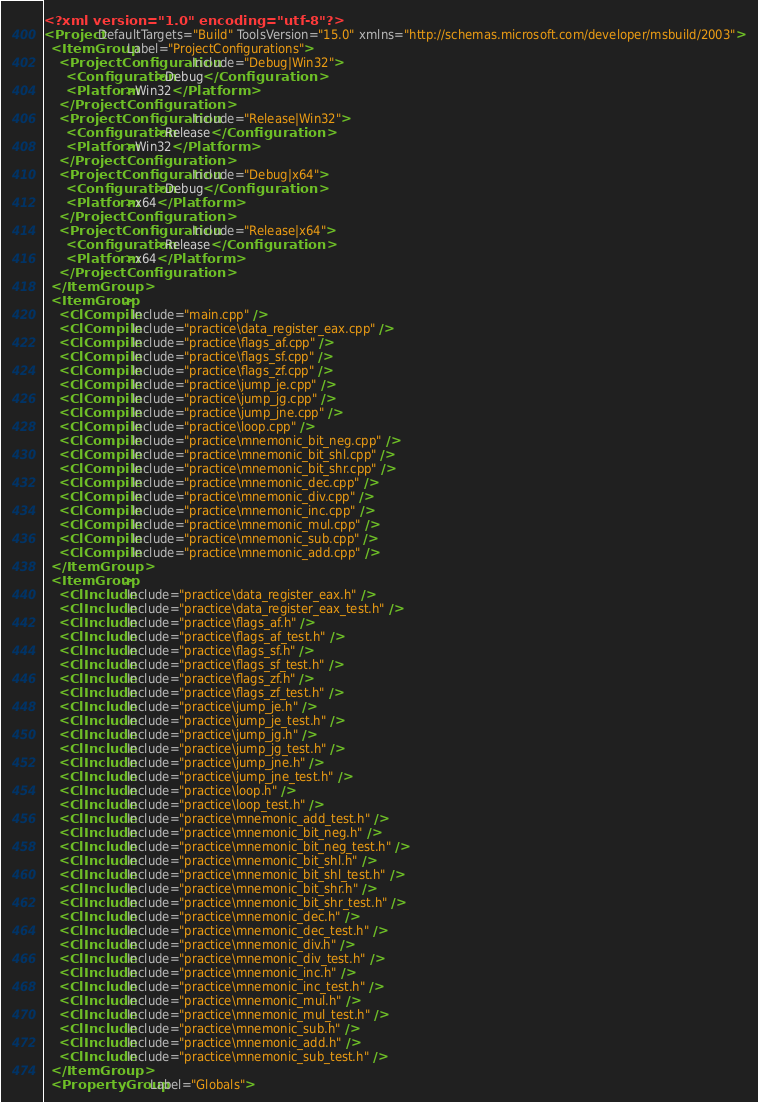<code> <loc_0><loc_0><loc_500><loc_500><_XML_><?xml version="1.0" encoding="utf-8"?>
<Project DefaultTargets="Build" ToolsVersion="15.0" xmlns="http://schemas.microsoft.com/developer/msbuild/2003">
  <ItemGroup Label="ProjectConfigurations">
    <ProjectConfiguration Include="Debug|Win32">
      <Configuration>Debug</Configuration>
      <Platform>Win32</Platform>
    </ProjectConfiguration>
    <ProjectConfiguration Include="Release|Win32">
      <Configuration>Release</Configuration>
      <Platform>Win32</Platform>
    </ProjectConfiguration>
    <ProjectConfiguration Include="Debug|x64">
      <Configuration>Debug</Configuration>
      <Platform>x64</Platform>
    </ProjectConfiguration>
    <ProjectConfiguration Include="Release|x64">
      <Configuration>Release</Configuration>
      <Platform>x64</Platform>
    </ProjectConfiguration>
  </ItemGroup>
  <ItemGroup>
    <ClCompile Include="main.cpp" />
    <ClCompile Include="practice\data_register_eax.cpp" />
    <ClCompile Include="practice\flags_af.cpp" />
    <ClCompile Include="practice\flags_sf.cpp" />
    <ClCompile Include="practice\flags_zf.cpp" />
    <ClCompile Include="practice\jump_je.cpp" />
    <ClCompile Include="practice\jump_jg.cpp" />
    <ClCompile Include="practice\jump_jne.cpp" />
    <ClCompile Include="practice\loop.cpp" />
    <ClCompile Include="practice\mnemonic_bit_neg.cpp" />
    <ClCompile Include="practice\mnemonic_bit_shl.cpp" />
    <ClCompile Include="practice\mnemonic_bit_shr.cpp" />
    <ClCompile Include="practice\mnemonic_dec.cpp" />
    <ClCompile Include="practice\mnemonic_div.cpp" />
    <ClCompile Include="practice\mnemonic_inc.cpp" />
    <ClCompile Include="practice\mnemonic_mul.cpp" />
    <ClCompile Include="practice\mnemonic_sub.cpp" />
    <ClCompile Include="practice\mnemonic_add.cpp" />
  </ItemGroup>
  <ItemGroup>
    <ClInclude Include="practice\data_register_eax.h" />
    <ClInclude Include="practice\data_register_eax_test.h" />
    <ClInclude Include="practice\flags_af.h" />
    <ClInclude Include="practice\flags_af_test.h" />
    <ClInclude Include="practice\flags_sf.h" />
    <ClInclude Include="practice\flags_sf_test.h" />
    <ClInclude Include="practice\flags_zf.h" />
    <ClInclude Include="practice\flags_zf_test.h" />
    <ClInclude Include="practice\jump_je.h" />
    <ClInclude Include="practice\jump_je_test.h" />
    <ClInclude Include="practice\jump_jg.h" />
    <ClInclude Include="practice\jump_jg_test.h" />
    <ClInclude Include="practice\jump_jne.h" />
    <ClInclude Include="practice\jump_jne_test.h" />
    <ClInclude Include="practice\loop.h" />
    <ClInclude Include="practice\loop_test.h" />
    <ClInclude Include="practice\mnemonic_add_test.h" />
    <ClInclude Include="practice\mnemonic_bit_neg.h" />
    <ClInclude Include="practice\mnemonic_bit_neg_test.h" />
    <ClInclude Include="practice\mnemonic_bit_shl.h" />
    <ClInclude Include="practice\mnemonic_bit_shl_test.h" />
    <ClInclude Include="practice\mnemonic_bit_shr.h" />
    <ClInclude Include="practice\mnemonic_bit_shr_test.h" />
    <ClInclude Include="practice\mnemonic_dec.h" />
    <ClInclude Include="practice\mnemonic_dec_test.h" />
    <ClInclude Include="practice\mnemonic_div.h" />
    <ClInclude Include="practice\mnemonic_div_test.h" />
    <ClInclude Include="practice\mnemonic_inc.h" />
    <ClInclude Include="practice\mnemonic_inc_test.h" />
    <ClInclude Include="practice\mnemonic_mul.h" />
    <ClInclude Include="practice\mnemonic_mul_test.h" />
    <ClInclude Include="practice\mnemonic_sub.h" />
    <ClInclude Include="practice\mnemonic_add.h" />
    <ClInclude Include="practice\mnemonic_sub_test.h" />
  </ItemGroup>
  <PropertyGroup Label="Globals"></code> 